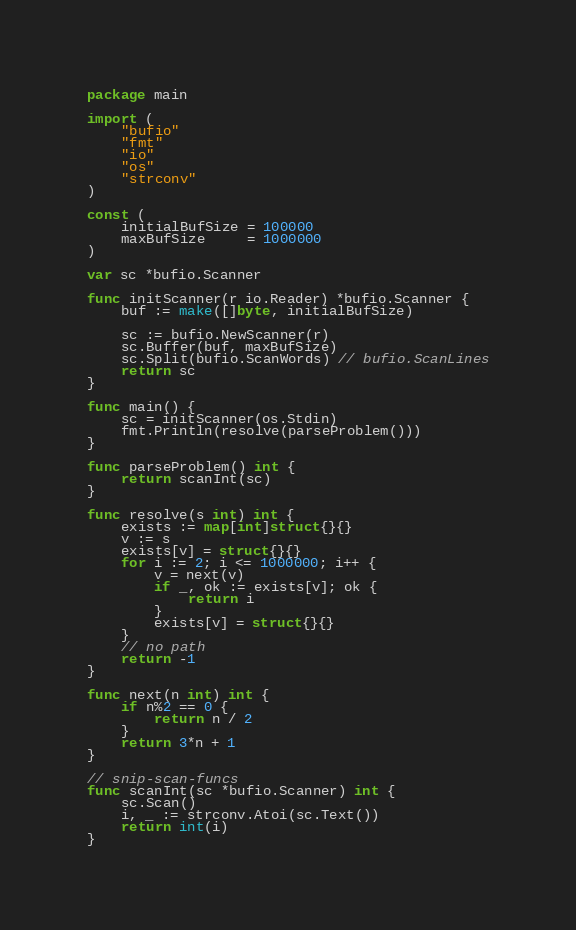<code> <loc_0><loc_0><loc_500><loc_500><_Go_>package main

import (
	"bufio"
	"fmt"
	"io"
	"os"
	"strconv"
)

const (
	initialBufSize = 100000
	maxBufSize     = 1000000
)

var sc *bufio.Scanner

func initScanner(r io.Reader) *bufio.Scanner {
	buf := make([]byte, initialBufSize)

	sc := bufio.NewScanner(r)
	sc.Buffer(buf, maxBufSize)
	sc.Split(bufio.ScanWords) // bufio.ScanLines
	return sc
}

func main() {
	sc = initScanner(os.Stdin)
	fmt.Println(resolve(parseProblem()))
}

func parseProblem() int {
	return scanInt(sc)
}

func resolve(s int) int {
	exists := map[int]struct{}{}
	v := s
	exists[v] = struct{}{}
	for i := 2; i <= 1000000; i++ {
		v = next(v)
		if _, ok := exists[v]; ok {
			return i
		}
		exists[v] = struct{}{}
	}
	// no path
	return -1
}

func next(n int) int {
	if n%2 == 0 {
		return n / 2
	}
	return 3*n + 1
}

// snip-scan-funcs
func scanInt(sc *bufio.Scanner) int {
	sc.Scan()
	i, _ := strconv.Atoi(sc.Text())
	return int(i)
}</code> 